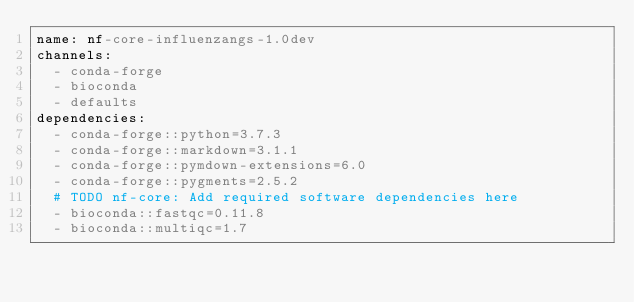<code> <loc_0><loc_0><loc_500><loc_500><_YAML_>name: nf-core-influenzangs-1.0dev
channels:
  - conda-forge
  - bioconda
  - defaults
dependencies:
  - conda-forge::python=3.7.3
  - conda-forge::markdown=3.1.1
  - conda-forge::pymdown-extensions=6.0
  - conda-forge::pygments=2.5.2
  # TODO nf-core: Add required software dependencies here
  - bioconda::fastqc=0.11.8
  - bioconda::multiqc=1.7
</code> 